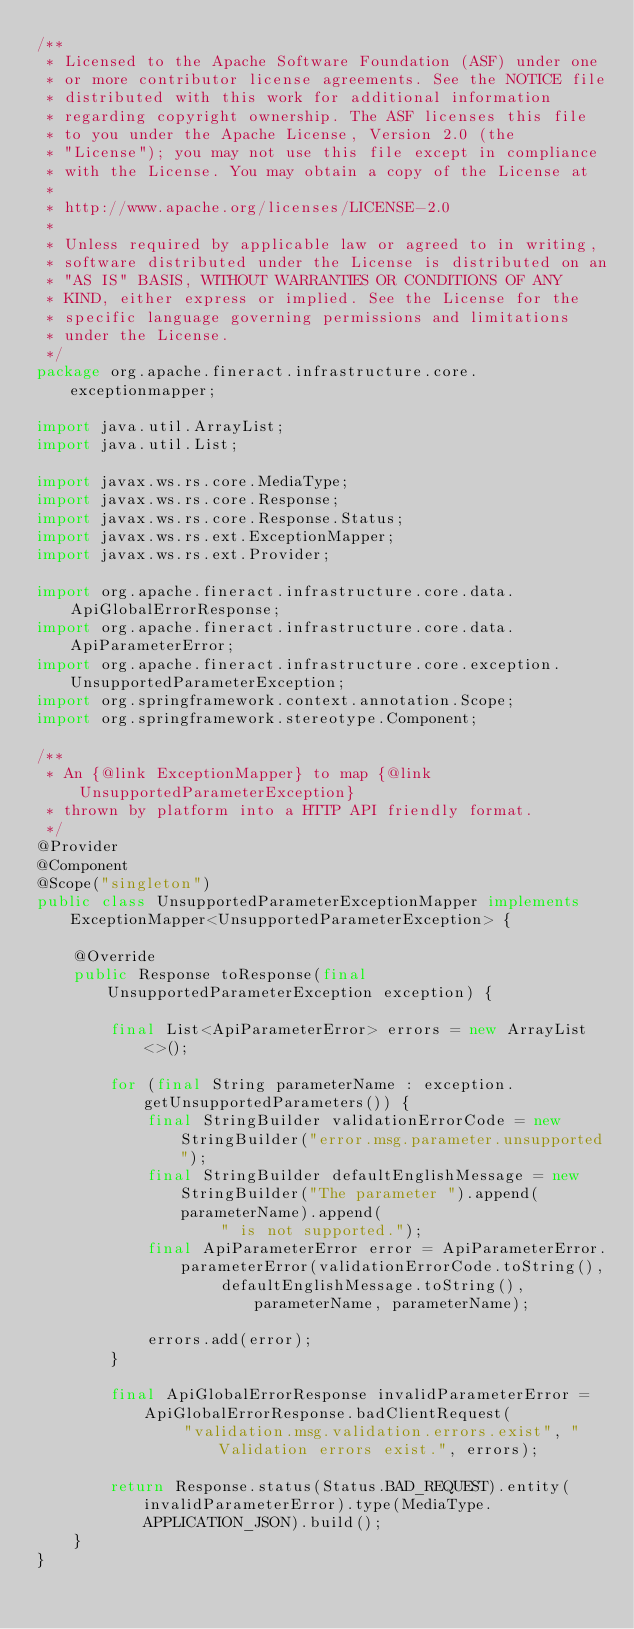Convert code to text. <code><loc_0><loc_0><loc_500><loc_500><_Java_>/**
 * Licensed to the Apache Software Foundation (ASF) under one
 * or more contributor license agreements. See the NOTICE file
 * distributed with this work for additional information
 * regarding copyright ownership. The ASF licenses this file
 * to you under the Apache License, Version 2.0 (the
 * "License"); you may not use this file except in compliance
 * with the License. You may obtain a copy of the License at
 *
 * http://www.apache.org/licenses/LICENSE-2.0
 *
 * Unless required by applicable law or agreed to in writing,
 * software distributed under the License is distributed on an
 * "AS IS" BASIS, WITHOUT WARRANTIES OR CONDITIONS OF ANY
 * KIND, either express or implied. See the License for the
 * specific language governing permissions and limitations
 * under the License.
 */
package org.apache.fineract.infrastructure.core.exceptionmapper;

import java.util.ArrayList;
import java.util.List;

import javax.ws.rs.core.MediaType;
import javax.ws.rs.core.Response;
import javax.ws.rs.core.Response.Status;
import javax.ws.rs.ext.ExceptionMapper;
import javax.ws.rs.ext.Provider;

import org.apache.fineract.infrastructure.core.data.ApiGlobalErrorResponse;
import org.apache.fineract.infrastructure.core.data.ApiParameterError;
import org.apache.fineract.infrastructure.core.exception.UnsupportedParameterException;
import org.springframework.context.annotation.Scope;
import org.springframework.stereotype.Component;

/**
 * An {@link ExceptionMapper} to map {@link UnsupportedParameterException}
 * thrown by platform into a HTTP API friendly format.
 */
@Provider
@Component
@Scope("singleton")
public class UnsupportedParameterExceptionMapper implements ExceptionMapper<UnsupportedParameterException> {

    @Override
    public Response toResponse(final UnsupportedParameterException exception) {

        final List<ApiParameterError> errors = new ArrayList<>();

        for (final String parameterName : exception.getUnsupportedParameters()) {
            final StringBuilder validationErrorCode = new StringBuilder("error.msg.parameter.unsupported");
            final StringBuilder defaultEnglishMessage = new StringBuilder("The parameter ").append(parameterName).append(
                    " is not supported.");
            final ApiParameterError error = ApiParameterError.parameterError(validationErrorCode.toString(),
                    defaultEnglishMessage.toString(), parameterName, parameterName);

            errors.add(error);
        }

        final ApiGlobalErrorResponse invalidParameterError = ApiGlobalErrorResponse.badClientRequest(
                "validation.msg.validation.errors.exist", "Validation errors exist.", errors);

        return Response.status(Status.BAD_REQUEST).entity(invalidParameterError).type(MediaType.APPLICATION_JSON).build();
    }
}</code> 